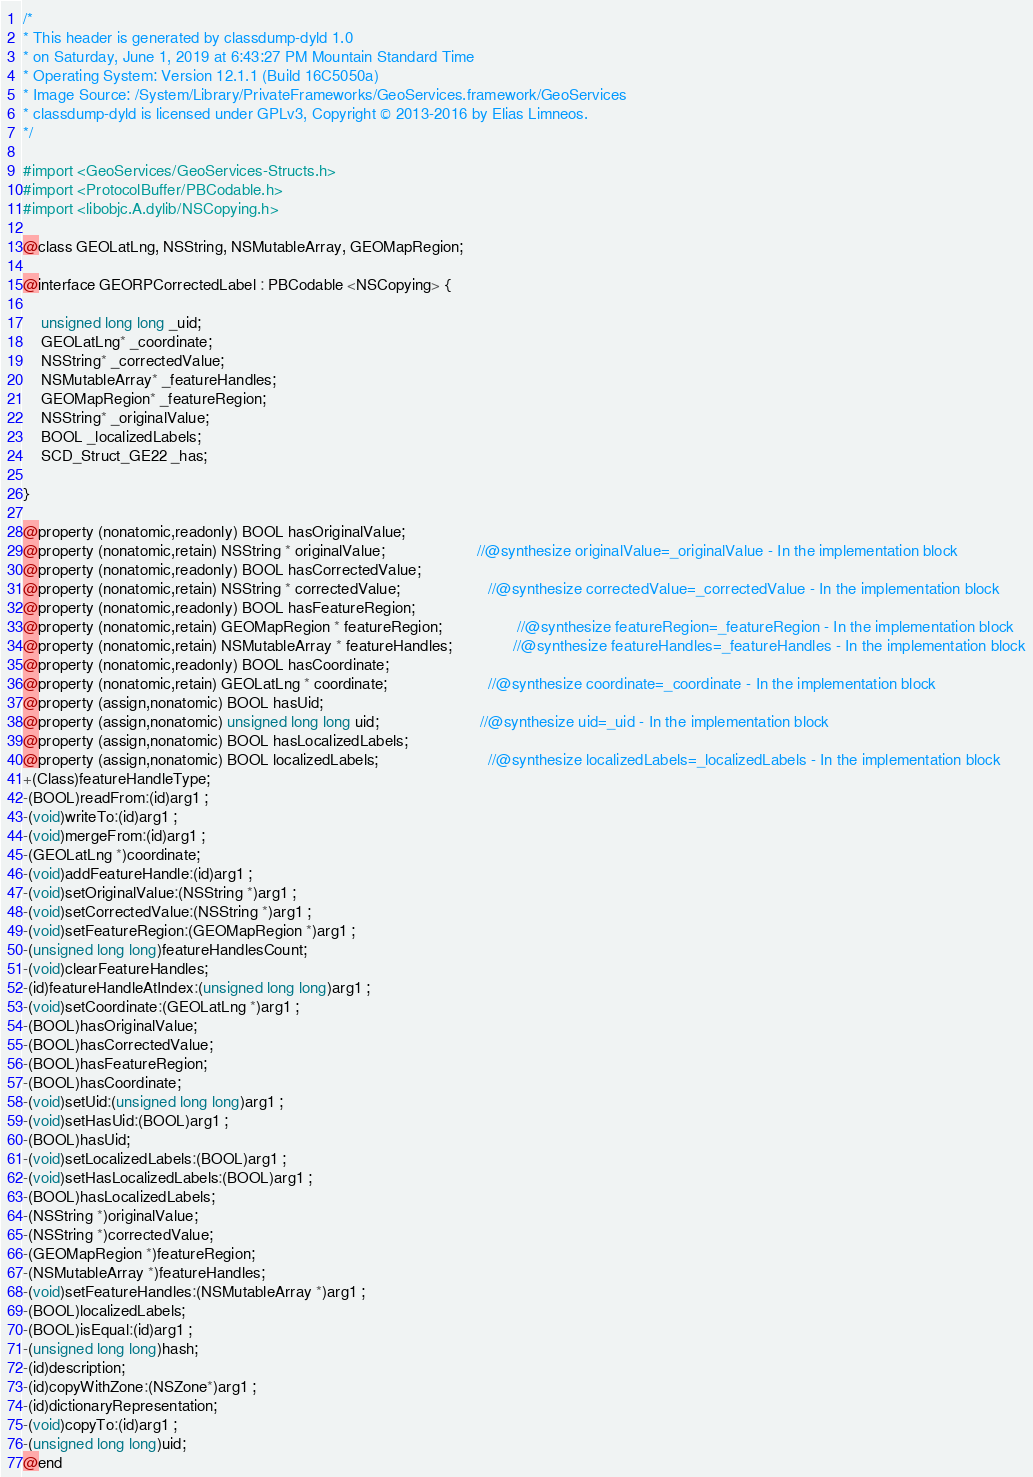<code> <loc_0><loc_0><loc_500><loc_500><_C_>/*
* This header is generated by classdump-dyld 1.0
* on Saturday, June 1, 2019 at 6:43:27 PM Mountain Standard Time
* Operating System: Version 12.1.1 (Build 16C5050a)
* Image Source: /System/Library/PrivateFrameworks/GeoServices.framework/GeoServices
* classdump-dyld is licensed under GPLv3, Copyright © 2013-2016 by Elias Limneos.
*/

#import <GeoServices/GeoServices-Structs.h>
#import <ProtocolBuffer/PBCodable.h>
#import <libobjc.A.dylib/NSCopying.h>

@class GEOLatLng, NSString, NSMutableArray, GEOMapRegion;

@interface GEORPCorrectedLabel : PBCodable <NSCopying> {

	unsigned long long _uid;
	GEOLatLng* _coordinate;
	NSString* _correctedValue;
	NSMutableArray* _featureHandles;
	GEOMapRegion* _featureRegion;
	NSString* _originalValue;
	BOOL _localizedLabels;
	SCD_Struct_GE22 _has;

}

@property (nonatomic,readonly) BOOL hasOriginalValue; 
@property (nonatomic,retain) NSString * originalValue;                     //@synthesize originalValue=_originalValue - In the implementation block
@property (nonatomic,readonly) BOOL hasCorrectedValue; 
@property (nonatomic,retain) NSString * correctedValue;                    //@synthesize correctedValue=_correctedValue - In the implementation block
@property (nonatomic,readonly) BOOL hasFeatureRegion; 
@property (nonatomic,retain) GEOMapRegion * featureRegion;                 //@synthesize featureRegion=_featureRegion - In the implementation block
@property (nonatomic,retain) NSMutableArray * featureHandles;              //@synthesize featureHandles=_featureHandles - In the implementation block
@property (nonatomic,readonly) BOOL hasCoordinate; 
@property (nonatomic,retain) GEOLatLng * coordinate;                       //@synthesize coordinate=_coordinate - In the implementation block
@property (assign,nonatomic) BOOL hasUid; 
@property (assign,nonatomic) unsigned long long uid;                       //@synthesize uid=_uid - In the implementation block
@property (assign,nonatomic) BOOL hasLocalizedLabels; 
@property (assign,nonatomic) BOOL localizedLabels;                         //@synthesize localizedLabels=_localizedLabels - In the implementation block
+(Class)featureHandleType;
-(BOOL)readFrom:(id)arg1 ;
-(void)writeTo:(id)arg1 ;
-(void)mergeFrom:(id)arg1 ;
-(GEOLatLng *)coordinate;
-(void)addFeatureHandle:(id)arg1 ;
-(void)setOriginalValue:(NSString *)arg1 ;
-(void)setCorrectedValue:(NSString *)arg1 ;
-(void)setFeatureRegion:(GEOMapRegion *)arg1 ;
-(unsigned long long)featureHandlesCount;
-(void)clearFeatureHandles;
-(id)featureHandleAtIndex:(unsigned long long)arg1 ;
-(void)setCoordinate:(GEOLatLng *)arg1 ;
-(BOOL)hasOriginalValue;
-(BOOL)hasCorrectedValue;
-(BOOL)hasFeatureRegion;
-(BOOL)hasCoordinate;
-(void)setUid:(unsigned long long)arg1 ;
-(void)setHasUid:(BOOL)arg1 ;
-(BOOL)hasUid;
-(void)setLocalizedLabels:(BOOL)arg1 ;
-(void)setHasLocalizedLabels:(BOOL)arg1 ;
-(BOOL)hasLocalizedLabels;
-(NSString *)originalValue;
-(NSString *)correctedValue;
-(GEOMapRegion *)featureRegion;
-(NSMutableArray *)featureHandles;
-(void)setFeatureHandles:(NSMutableArray *)arg1 ;
-(BOOL)localizedLabels;
-(BOOL)isEqual:(id)arg1 ;
-(unsigned long long)hash;
-(id)description;
-(id)copyWithZone:(NSZone*)arg1 ;
-(id)dictionaryRepresentation;
-(void)copyTo:(id)arg1 ;
-(unsigned long long)uid;
@end

</code> 